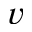<formula> <loc_0><loc_0><loc_500><loc_500>v</formula> 